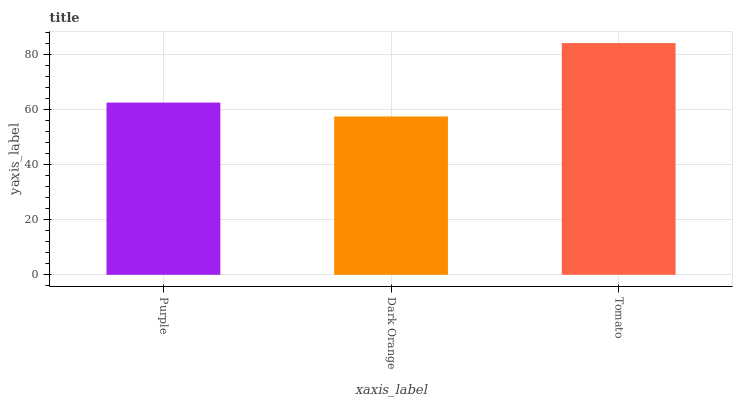Is Dark Orange the minimum?
Answer yes or no. Yes. Is Tomato the maximum?
Answer yes or no. Yes. Is Tomato the minimum?
Answer yes or no. No. Is Dark Orange the maximum?
Answer yes or no. No. Is Tomato greater than Dark Orange?
Answer yes or no. Yes. Is Dark Orange less than Tomato?
Answer yes or no. Yes. Is Dark Orange greater than Tomato?
Answer yes or no. No. Is Tomato less than Dark Orange?
Answer yes or no. No. Is Purple the high median?
Answer yes or no. Yes. Is Purple the low median?
Answer yes or no. Yes. Is Tomato the high median?
Answer yes or no. No. Is Dark Orange the low median?
Answer yes or no. No. 